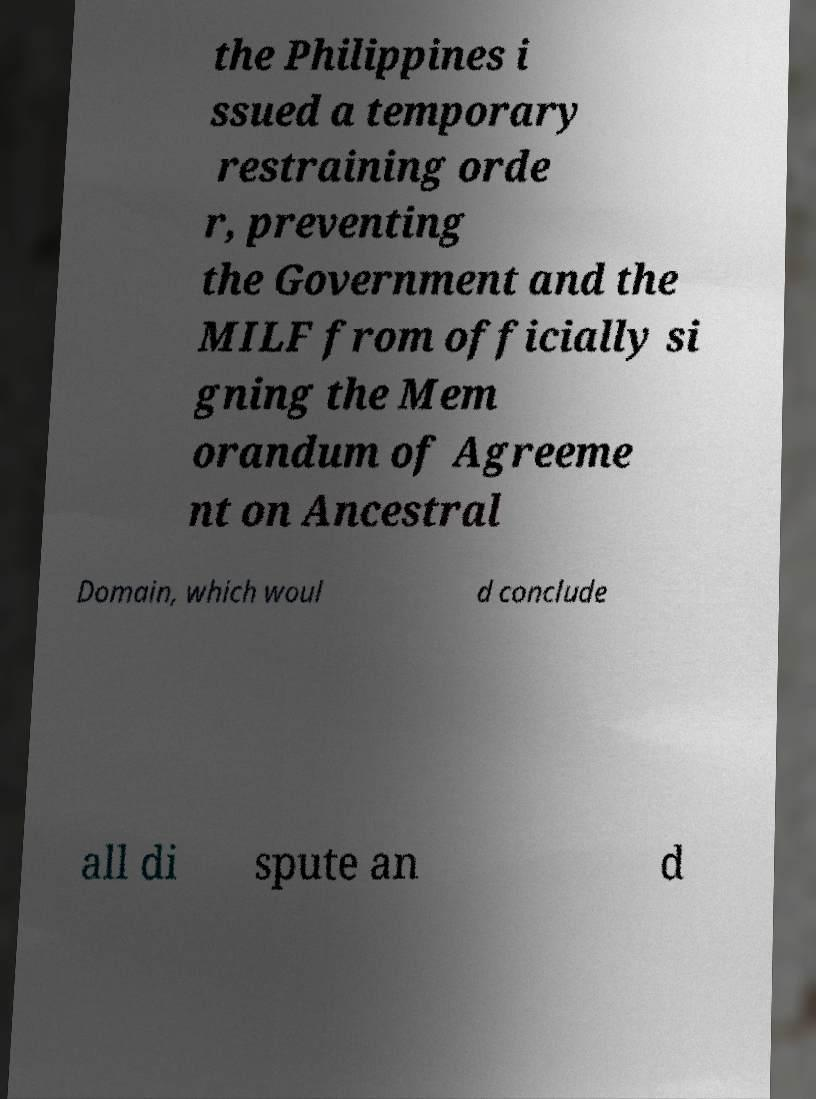Can you accurately transcribe the text from the provided image for me? the Philippines i ssued a temporary restraining orde r, preventing the Government and the MILF from officially si gning the Mem orandum of Agreeme nt on Ancestral Domain, which woul d conclude all di spute an d 